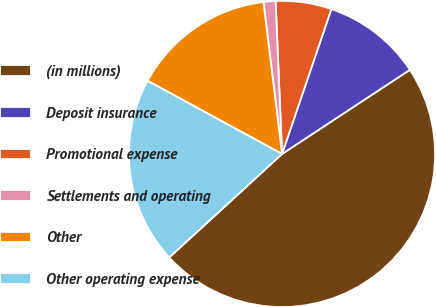Convert chart. <chart><loc_0><loc_0><loc_500><loc_500><pie_chart><fcel>(in millions)<fcel>Deposit insurance<fcel>Promotional expense<fcel>Settlements and operating<fcel>Other<fcel>Other operating expense<nl><fcel>47.46%<fcel>10.51%<fcel>5.89%<fcel>1.27%<fcel>15.13%<fcel>19.75%<nl></chart> 